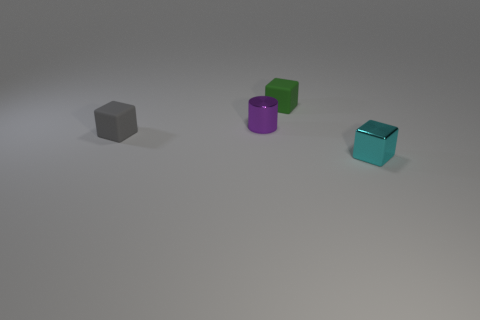If we consider the surface to be part of a larger scene, what purpose could these objects serve? In a larger scene, these objects could be part of a minimalist art installation intended to evoke thought on geometry and color. Alternatively, they might represent product models on display for a design exhibition, showcasing the simplicity and aesthetics of modern design. 